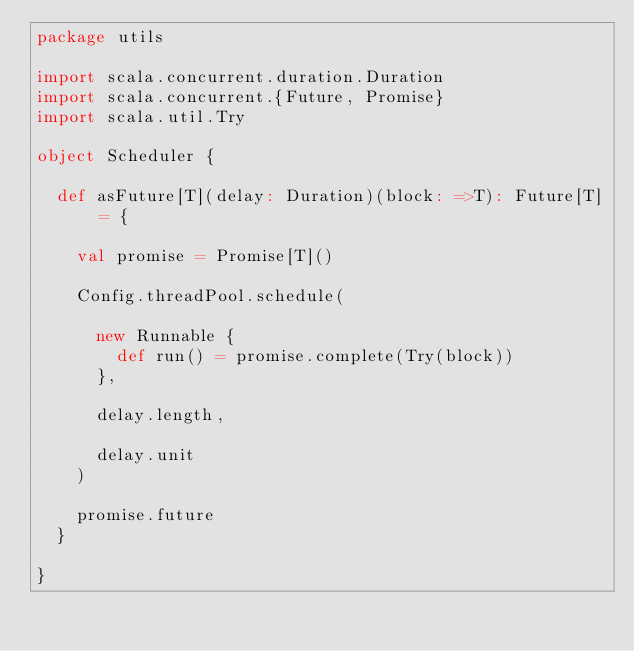Convert code to text. <code><loc_0><loc_0><loc_500><loc_500><_Scala_>package utils

import scala.concurrent.duration.Duration
import scala.concurrent.{Future, Promise}
import scala.util.Try

object Scheduler {

  def asFuture[T](delay: Duration)(block: =>T): Future[T] = {

    val promise = Promise[T]()

    Config.threadPool.schedule(

      new Runnable {
        def run() = promise.complete(Try(block))
      },

      delay.length,

      delay.unit
    )

    promise.future
  }

}
</code> 